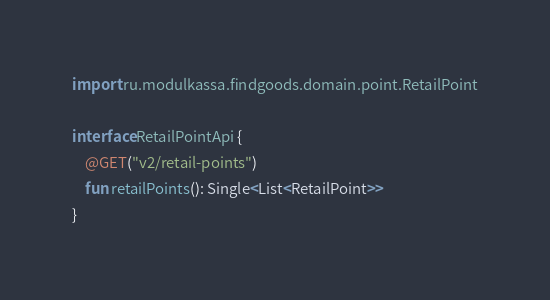<code> <loc_0><loc_0><loc_500><loc_500><_Kotlin_>import ru.modulkassa.findgoods.domain.point.RetailPoint

interface RetailPointApi {
    @GET("v2/retail-points")
    fun retailPoints(): Single<List<RetailPoint>>
}</code> 